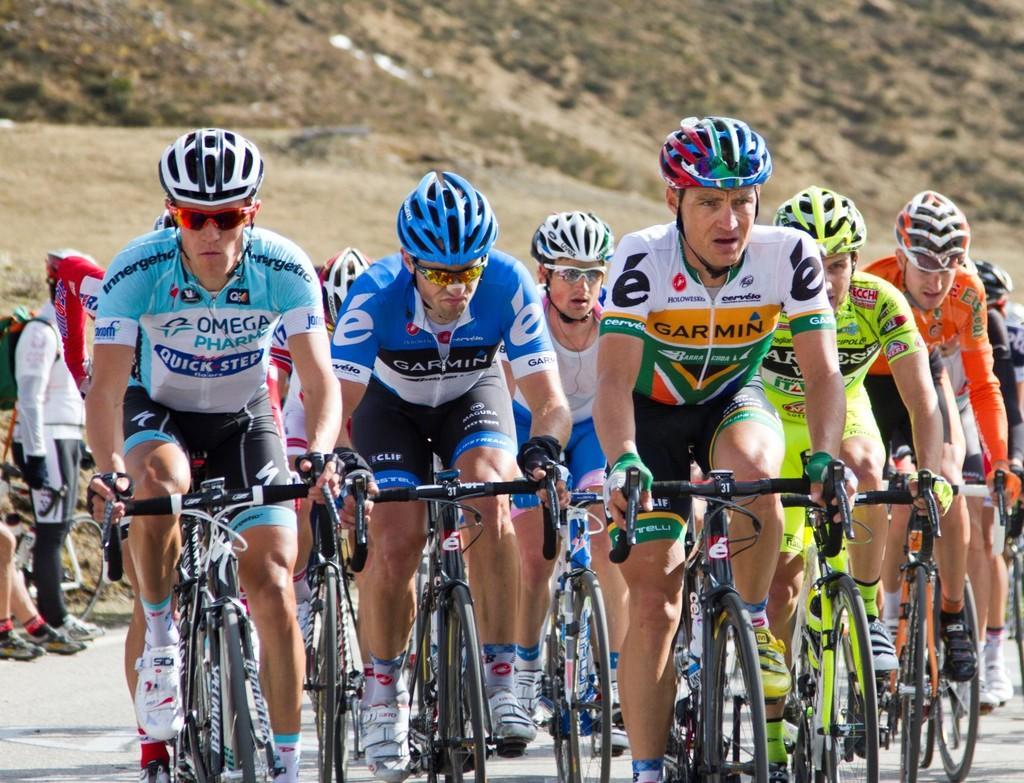In one or two sentences, can you explain what this image depicts? In this picture there is a group of men wearing t-shirt and helmets, doing a cycling on the street. Behind there is a mountain. 